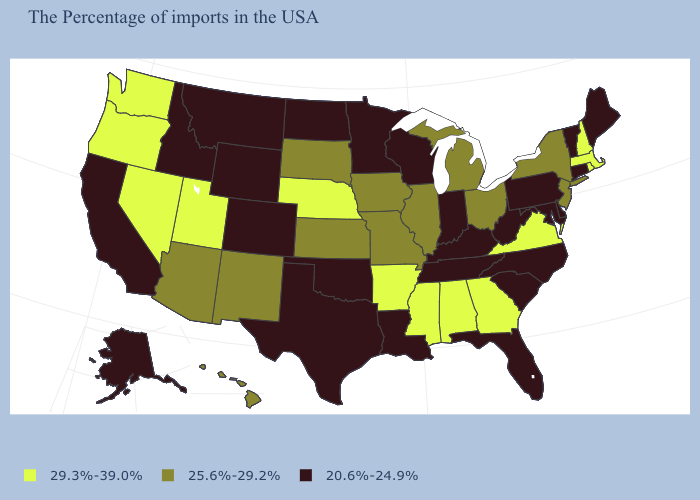What is the value of Alaska?
Be succinct. 20.6%-24.9%. Among the states that border Nebraska , does Iowa have the highest value?
Concise answer only. Yes. What is the value of Colorado?
Write a very short answer. 20.6%-24.9%. What is the value of Ohio?
Answer briefly. 25.6%-29.2%. Which states have the lowest value in the USA?
Concise answer only. Maine, Vermont, Connecticut, Delaware, Maryland, Pennsylvania, North Carolina, South Carolina, West Virginia, Florida, Kentucky, Indiana, Tennessee, Wisconsin, Louisiana, Minnesota, Oklahoma, Texas, North Dakota, Wyoming, Colorado, Montana, Idaho, California, Alaska. What is the value of Missouri?
Answer briefly. 25.6%-29.2%. Name the states that have a value in the range 25.6%-29.2%?
Give a very brief answer. New York, New Jersey, Ohio, Michigan, Illinois, Missouri, Iowa, Kansas, South Dakota, New Mexico, Arizona, Hawaii. What is the highest value in the MidWest ?
Keep it brief. 29.3%-39.0%. Among the states that border Kansas , does Colorado have the lowest value?
Quick response, please. Yes. How many symbols are there in the legend?
Write a very short answer. 3. What is the value of Colorado?
Give a very brief answer. 20.6%-24.9%. Among the states that border Mississippi , does Louisiana have the highest value?
Write a very short answer. No. Is the legend a continuous bar?
Concise answer only. No. What is the value of Colorado?
Quick response, please. 20.6%-24.9%. Does Wisconsin have the lowest value in the MidWest?
Answer briefly. Yes. 